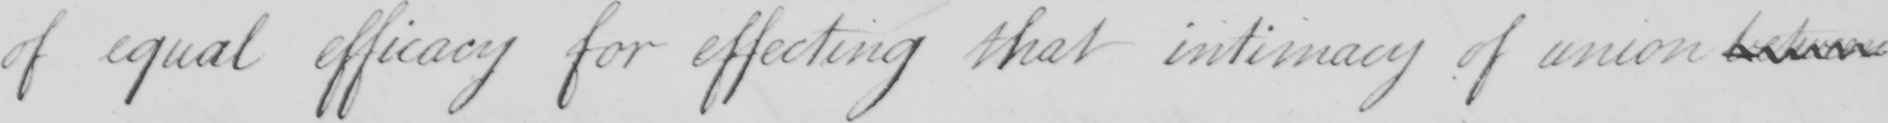Please transcribe the handwritten text in this image. of equal efficacy for effecting that intimacy of union between 